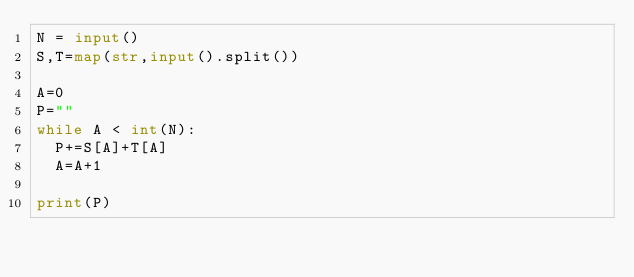Convert code to text. <code><loc_0><loc_0><loc_500><loc_500><_Python_>N = input()
S,T=map(str,input().split())

A=0
P=""
while A < int(N):
  P+=S[A]+T[A]
  A=A+1

print(P)</code> 